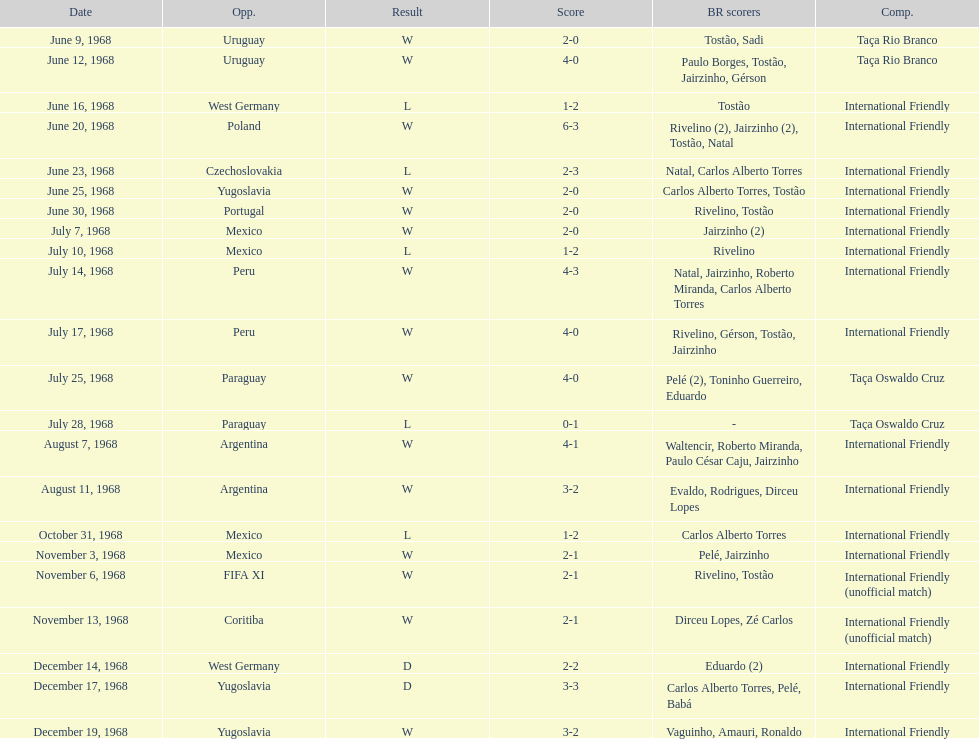Number of losses 5. 